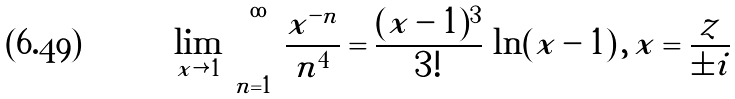Convert formula to latex. <formula><loc_0><loc_0><loc_500><loc_500>\lim _ { x \rightarrow 1 } \, \sum _ { n = 1 } ^ { \infty } \frac { x ^ { - n } } { n ^ { 4 } } = \frac { ( x - 1 ) ^ { 3 } } { 3 ! } \, \ln ( x - 1 ) \, , \, x = \frac { z } { \pm i }</formula> 